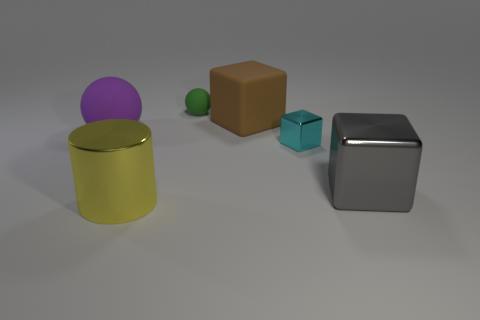Subtract all matte blocks. How many blocks are left? 2 Add 2 brown blocks. How many objects exist? 8 Subtract all cyan cubes. How many cubes are left? 2 Subtract all spheres. How many objects are left? 4 Subtract all rubber things. Subtract all cyan shiny blocks. How many objects are left? 2 Add 1 brown matte blocks. How many brown matte blocks are left? 2 Add 3 rubber spheres. How many rubber spheres exist? 5 Subtract 0 purple cylinders. How many objects are left? 6 Subtract all gray spheres. Subtract all red cylinders. How many spheres are left? 2 